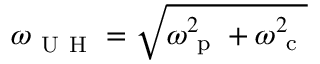Convert formula to latex. <formula><loc_0><loc_0><loc_500><loc_500>\omega _ { U H } = \sqrt { \omega _ { p } ^ { 2 } + \omega _ { c } ^ { 2 } }</formula> 